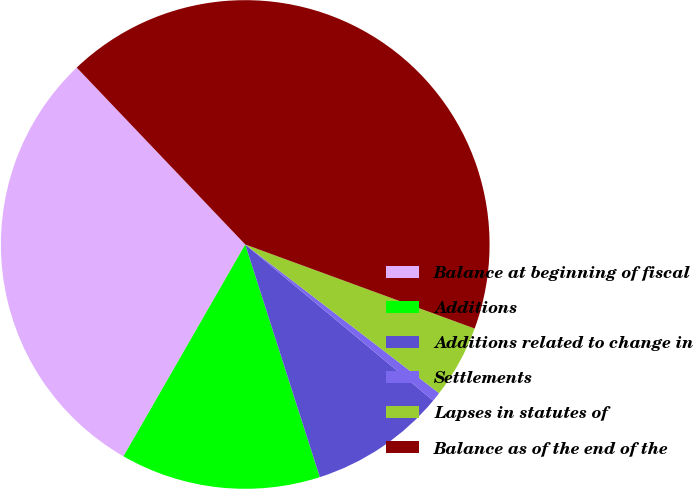Convert chart to OTSL. <chart><loc_0><loc_0><loc_500><loc_500><pie_chart><fcel>Balance at beginning of fiscal<fcel>Additions<fcel>Additions related to change in<fcel>Settlements<fcel>Lapses in statutes of<fcel>Balance as of the end of the<nl><fcel>29.58%<fcel>13.24%<fcel>9.03%<fcel>0.62%<fcel>4.82%<fcel>42.7%<nl></chart> 